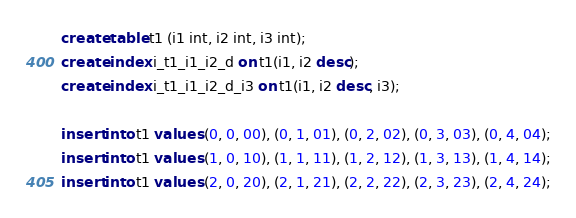Convert code to text. <code><loc_0><loc_0><loc_500><loc_500><_SQL_>
create table t1 (i1 int, i2 int, i3 int);
create index i_t1_i1_i2_d on t1(i1, i2 desc);
create index i_t1_i1_i2_d_i3 on t1(i1, i2 desc, i3);

insert into t1 values (0, 0, 00), (0, 1, 01), (0, 2, 02), (0, 3, 03), (0, 4, 04);
insert into t1 values (1, 0, 10), (1, 1, 11), (1, 2, 12), (1, 3, 13), (1, 4, 14);
insert into t1 values (2, 0, 20), (2, 1, 21), (2, 2, 22), (2, 3, 23), (2, 4, 24);</code> 